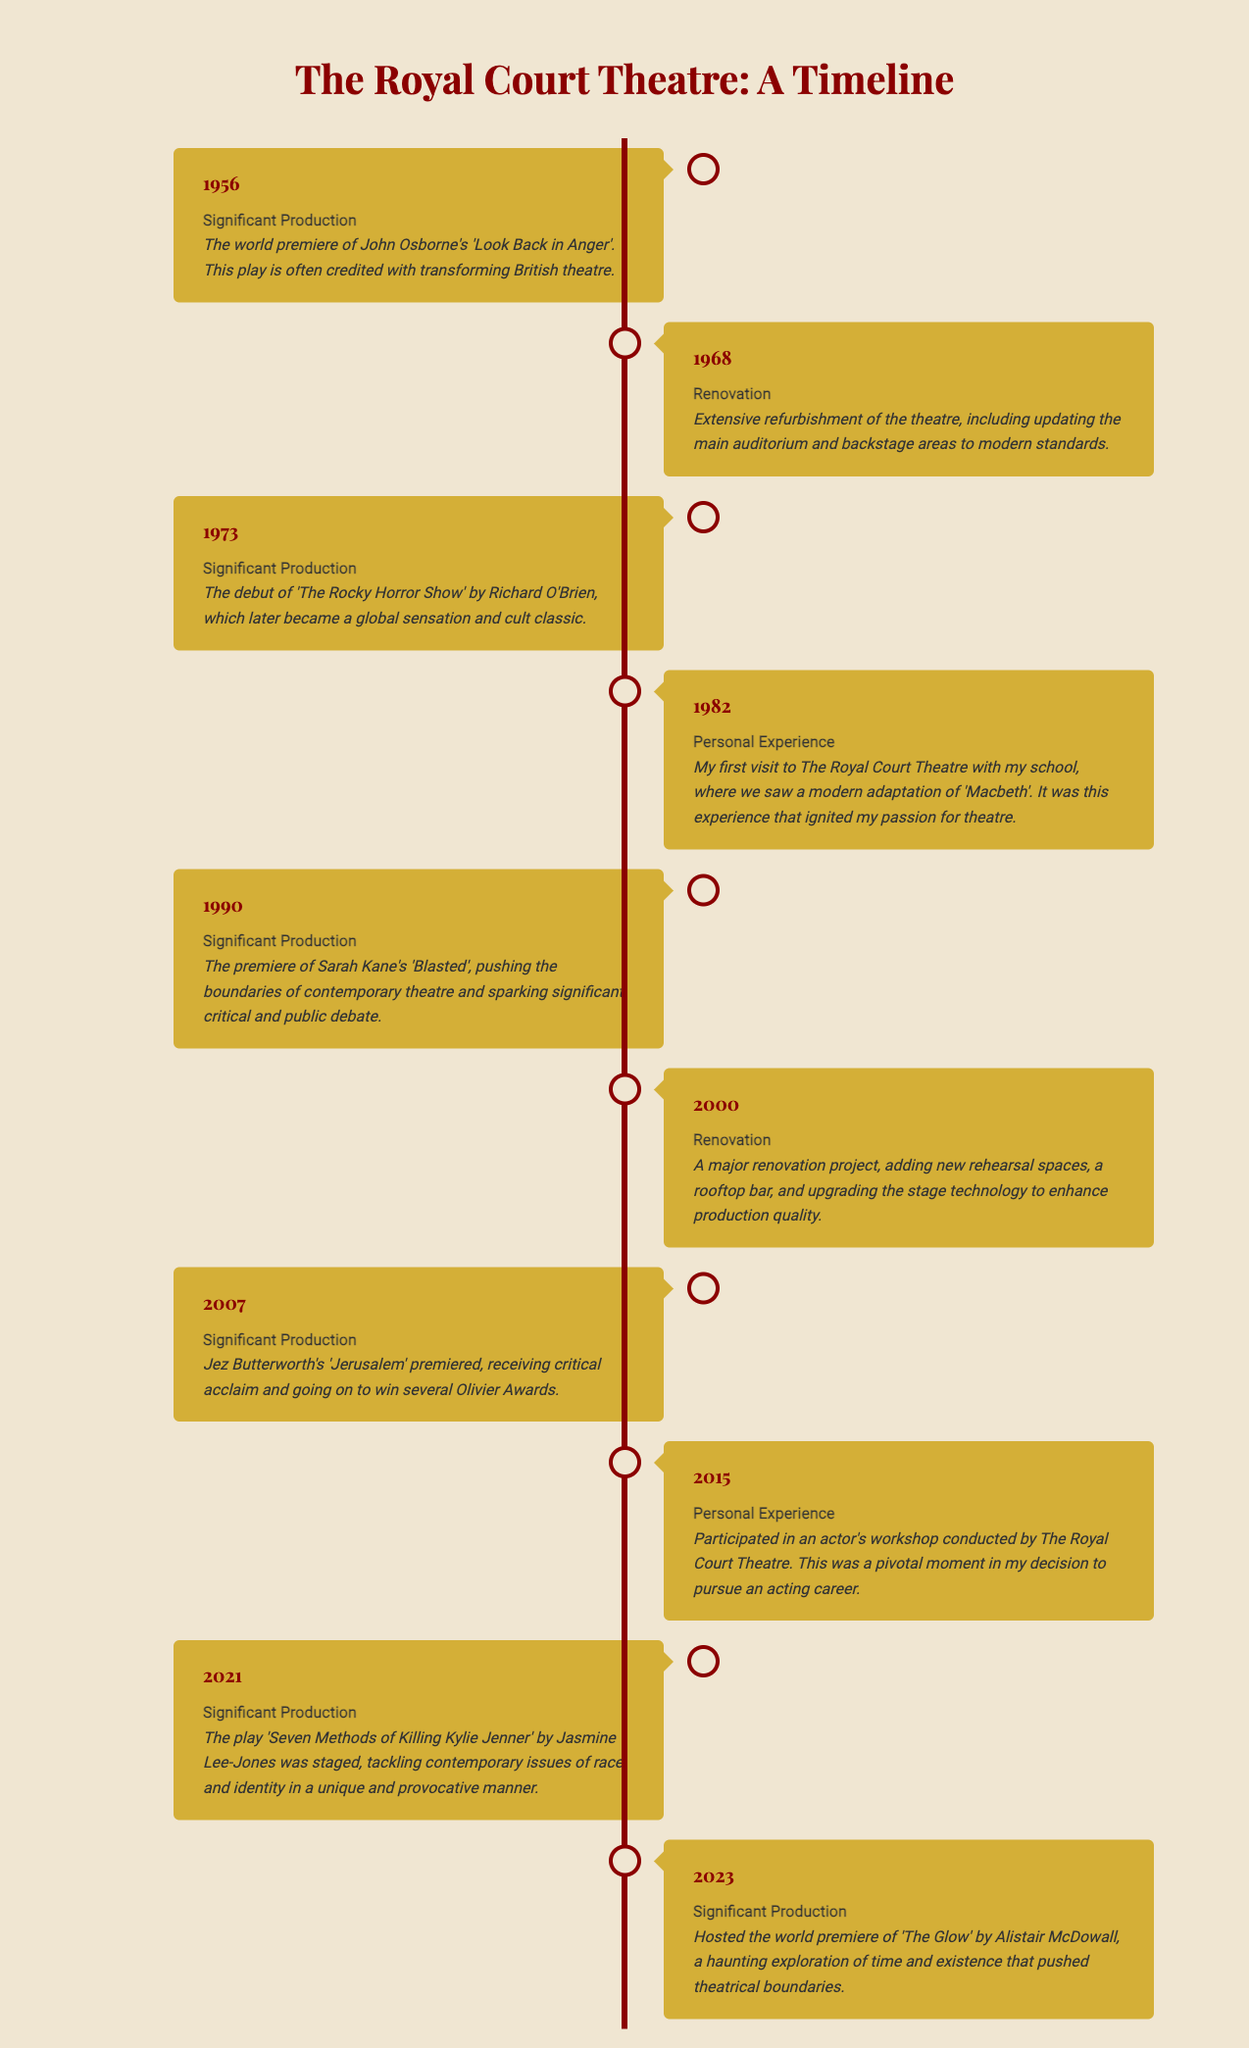what was the world premiere in 1956? The world premiere listed in 1956 is John Osborne's 'Look Back in Anger', which transformed British theatre.
Answer: 'Look Back in Anger' what significant production debuted in 1973? The production that debuted in 1973 is 'The Rocky Horror Show' by Richard O'Brien.
Answer: 'The Rocky Horror Show' what renovation occurred in 2000? The renovation in 2000 included adding new rehearsal spaces, a rooftop bar, and upgrading stage technology.
Answer: Major renovation project what personal experience happened in 1982? In 1982, a personal experience involved visiting the Royal Court Theatre with school to see a modern adaptation of 'Macbeth'.
Answer: My first visit with school how many significant productions are mentioned? The number of significant productions mentioned in the timeline is a count of all events labeled as significant productions.
Answer: 6 which play pushed boundaries in 1990? The play that pushed the boundaries in 1990 is Sarah Kane's 'Blasted'.
Answer: 'Blasted' which year did 'Jerusalem' premiere? The year 'Jerusalem' premiered is 2007.
Answer: 2007 what was the last significant production listed? The last significant production listed in the timeline occurred in 2023.
Answer: 'The Glow' which type of events are listed in this timeline? The types of events listed in this timeline include significant productions, renovations, and personal experiences.
Answer: Significant productions, renovations, personal experiences 